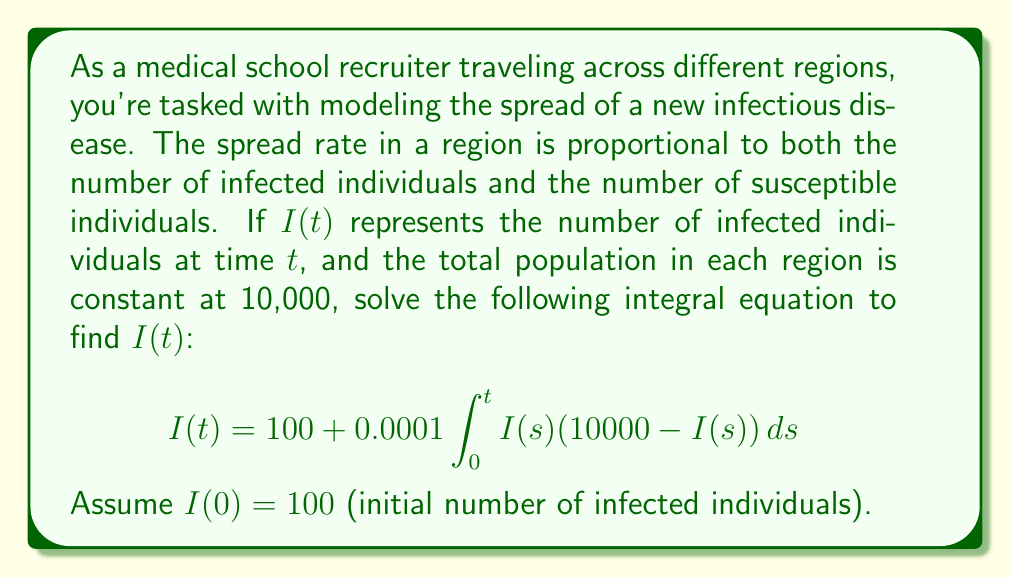Can you answer this question? To solve this integral equation, we'll use the following steps:

1) First, we recognize this as a Volterra integral equation of the second kind. The general form is:

   $$I(t) = f(t) + \int_0^t K(t,s)I(s)ds$$

   where $f(t) = 100$ and $K(t,s) = 0.0001(10000 - I(s))$

2) To solve this, we can differentiate both sides with respect to $t$:

   $$\frac{dI}{dt} = 0 + K(t,t)I(t) + \int_0^t \frac{\partial K(t,s)}{\partial t}I(s)ds$$

3) In our case, $K(t,s)$ doesn't depend on $t$ explicitly, so $\frac{\partial K(t,s)}{\partial t} = 0$. Thus:

   $$\frac{dI}{dt} = 0.0001(10000 - I(t))I(t) = I(t)(1 - 0.0001I(t))$$

4) This is a separable differential equation. We can solve it as follows:

   $$\frac{dI}{I(1 - 0.0001I)} = dt$$

5) Integrating both sides:

   $$\int \frac{dI}{I(1 - 0.0001I)} = \int dt$$

6) The left side can be integrated using partial fractions:

   $$-10000\ln|1 - 0.0001I| - \ln|I| = t + C$$

7) Using the initial condition $I(0) = 100$, we can solve for $C$:

   $$C = -10000\ln|0.99| - \ln|100| \approx 104.6$$

8) Therefore, the solution is:

   $$-10000\ln|1 - 0.0001I| - \ln|I| = t + 104.6$$

9) This can be rearranged to:

   $$I(t) = \frac{10000}{1 + 99e^{-0.0001t}}$$
Answer: $I(t) = \frac{10000}{1 + 99e^{-0.0001t}}$ 